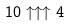<formula> <loc_0><loc_0><loc_500><loc_500>1 0 \uparrow \uparrow \uparrow 4</formula> 